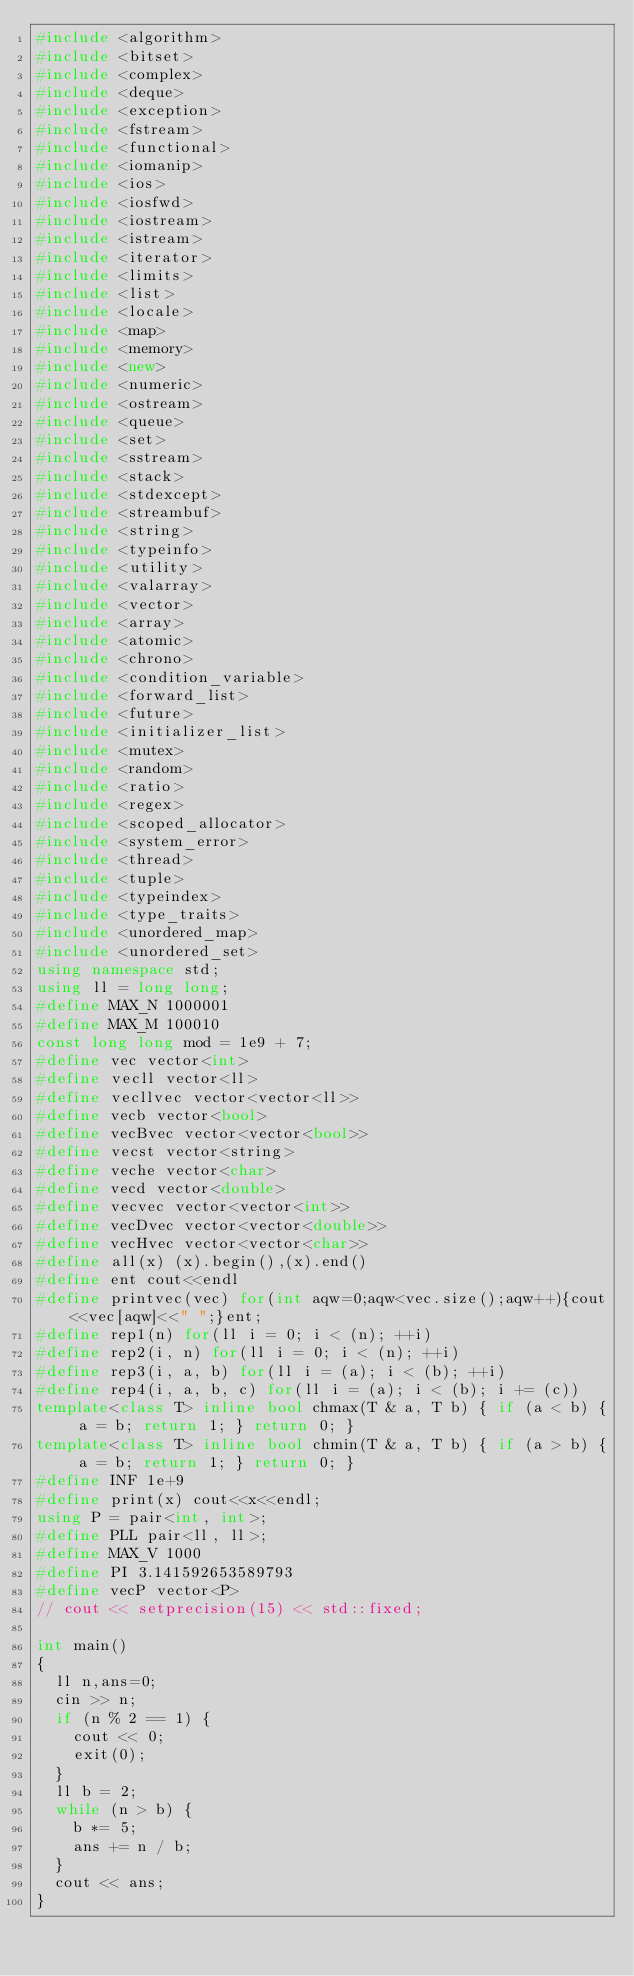Convert code to text. <code><loc_0><loc_0><loc_500><loc_500><_C++_>#include <algorithm>
#include <bitset>
#include <complex>
#include <deque>
#include <exception>
#include <fstream>
#include <functional>
#include <iomanip>
#include <ios>
#include <iosfwd>
#include <iostream>
#include <istream>
#include <iterator>
#include <limits>
#include <list>
#include <locale>
#include <map>
#include <memory>
#include <new>
#include <numeric>
#include <ostream>
#include <queue>
#include <set>
#include <sstream>
#include <stack>
#include <stdexcept>
#include <streambuf>
#include <string>
#include <typeinfo>
#include <utility>
#include <valarray>
#include <vector>
#include <array>
#include <atomic>
#include <chrono>
#include <condition_variable>
#include <forward_list>
#include <future>
#include <initializer_list>
#include <mutex>
#include <random>
#include <ratio>
#include <regex>
#include <scoped_allocator>
#include <system_error>
#include <thread>
#include <tuple>
#include <typeindex>
#include <type_traits>
#include <unordered_map>
#include <unordered_set>
using namespace std;
using ll = long long;
#define MAX_N 1000001
#define MAX_M 100010
const long long mod = 1e9 + 7;
#define vec vector<int>
#define vecll vector<ll>
#define vecllvec vector<vector<ll>>
#define vecb vector<bool>
#define vecBvec vector<vector<bool>>
#define vecst vector<string>
#define veche vector<char>
#define vecd vector<double>
#define vecvec vector<vector<int>>
#define vecDvec vector<vector<double>>
#define vecHvec vector<vector<char>>
#define all(x) (x).begin(),(x).end()
#define ent cout<<endl
#define printvec(vec) for(int aqw=0;aqw<vec.size();aqw++){cout<<vec[aqw]<<" ";}ent;
#define rep1(n) for(ll i = 0; i < (n); ++i)
#define rep2(i, n) for(ll i = 0; i < (n); ++i)
#define rep3(i, a, b) for(ll i = (a); i < (b); ++i)
#define rep4(i, a, b, c) for(ll i = (a); i < (b); i += (c))
template<class T> inline bool chmax(T & a, T b) { if (a < b) { a = b; return 1; } return 0; }
template<class T> inline bool chmin(T & a, T b) { if (a > b) { a = b; return 1; } return 0; }
#define INF 1e+9
#define print(x) cout<<x<<endl;
using P = pair<int, int>;
#define PLL pair<ll, ll>;
#define MAX_V 1000
#define PI 3.141592653589793
#define vecP vector<P>
// cout << setprecision(15) << std::fixed;

int main()
{
	ll n,ans=0;
	cin >> n;
	if (n % 2 == 1) {
		cout << 0;
		exit(0);
	}
	ll b = 2;
	while (n > b) {
		b *= 5;
		ans += n / b;
	}
	cout << ans;
}
</code> 